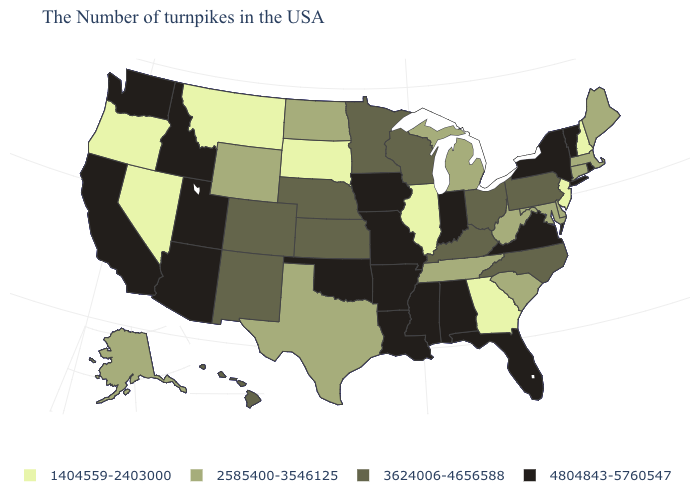Name the states that have a value in the range 2585400-3546125?
Answer briefly. Maine, Massachusetts, Connecticut, Delaware, Maryland, South Carolina, West Virginia, Michigan, Tennessee, Texas, North Dakota, Wyoming, Alaska. What is the value of Texas?
Be succinct. 2585400-3546125. Name the states that have a value in the range 1404559-2403000?
Keep it brief. New Hampshire, New Jersey, Georgia, Illinois, South Dakota, Montana, Nevada, Oregon. What is the value of North Dakota?
Short answer required. 2585400-3546125. Is the legend a continuous bar?
Concise answer only. No. Does Illinois have the lowest value in the MidWest?
Concise answer only. Yes. What is the lowest value in the South?
Short answer required. 1404559-2403000. What is the value of Vermont?
Short answer required. 4804843-5760547. Does Missouri have the highest value in the MidWest?
Write a very short answer. Yes. Does Wyoming have a lower value than Oregon?
Quick response, please. No. Name the states that have a value in the range 4804843-5760547?
Be succinct. Rhode Island, Vermont, New York, Virginia, Florida, Indiana, Alabama, Mississippi, Louisiana, Missouri, Arkansas, Iowa, Oklahoma, Utah, Arizona, Idaho, California, Washington. What is the value of Delaware?
Short answer required. 2585400-3546125. Name the states that have a value in the range 2585400-3546125?
Give a very brief answer. Maine, Massachusetts, Connecticut, Delaware, Maryland, South Carolina, West Virginia, Michigan, Tennessee, Texas, North Dakota, Wyoming, Alaska. Name the states that have a value in the range 4804843-5760547?
Short answer required. Rhode Island, Vermont, New York, Virginia, Florida, Indiana, Alabama, Mississippi, Louisiana, Missouri, Arkansas, Iowa, Oklahoma, Utah, Arizona, Idaho, California, Washington. Among the states that border Colorado , does Wyoming have the lowest value?
Be succinct. Yes. 